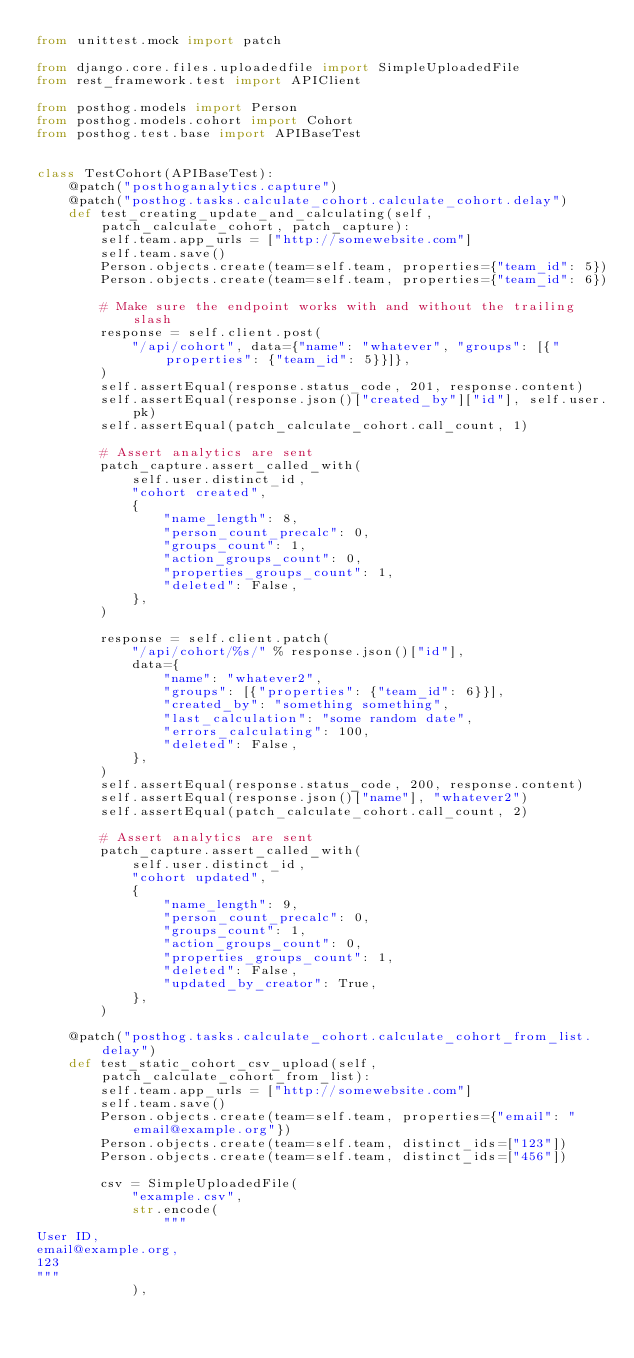<code> <loc_0><loc_0><loc_500><loc_500><_Python_>from unittest.mock import patch

from django.core.files.uploadedfile import SimpleUploadedFile
from rest_framework.test import APIClient

from posthog.models import Person
from posthog.models.cohort import Cohort
from posthog.test.base import APIBaseTest


class TestCohort(APIBaseTest):
    @patch("posthoganalytics.capture")
    @patch("posthog.tasks.calculate_cohort.calculate_cohort.delay")
    def test_creating_update_and_calculating(self, patch_calculate_cohort, patch_capture):
        self.team.app_urls = ["http://somewebsite.com"]
        self.team.save()
        Person.objects.create(team=self.team, properties={"team_id": 5})
        Person.objects.create(team=self.team, properties={"team_id": 6})

        # Make sure the endpoint works with and without the trailing slash
        response = self.client.post(
            "/api/cohort", data={"name": "whatever", "groups": [{"properties": {"team_id": 5}}]},
        )
        self.assertEqual(response.status_code, 201, response.content)
        self.assertEqual(response.json()["created_by"]["id"], self.user.pk)
        self.assertEqual(patch_calculate_cohort.call_count, 1)

        # Assert analytics are sent
        patch_capture.assert_called_with(
            self.user.distinct_id,
            "cohort created",
            {
                "name_length": 8,
                "person_count_precalc": 0,
                "groups_count": 1,
                "action_groups_count": 0,
                "properties_groups_count": 1,
                "deleted": False,
            },
        )

        response = self.client.patch(
            "/api/cohort/%s/" % response.json()["id"],
            data={
                "name": "whatever2",
                "groups": [{"properties": {"team_id": 6}}],
                "created_by": "something something",
                "last_calculation": "some random date",
                "errors_calculating": 100,
                "deleted": False,
            },
        )
        self.assertEqual(response.status_code, 200, response.content)
        self.assertEqual(response.json()["name"], "whatever2")
        self.assertEqual(patch_calculate_cohort.call_count, 2)

        # Assert analytics are sent
        patch_capture.assert_called_with(
            self.user.distinct_id,
            "cohort updated",
            {
                "name_length": 9,
                "person_count_precalc": 0,
                "groups_count": 1,
                "action_groups_count": 0,
                "properties_groups_count": 1,
                "deleted": False,
                "updated_by_creator": True,
            },
        )

    @patch("posthog.tasks.calculate_cohort.calculate_cohort_from_list.delay")
    def test_static_cohort_csv_upload(self, patch_calculate_cohort_from_list):
        self.team.app_urls = ["http://somewebsite.com"]
        self.team.save()
        Person.objects.create(team=self.team, properties={"email": "email@example.org"})
        Person.objects.create(team=self.team, distinct_ids=["123"])
        Person.objects.create(team=self.team, distinct_ids=["456"])

        csv = SimpleUploadedFile(
            "example.csv",
            str.encode(
                """
User ID,
email@example.org,
123
"""
            ),</code> 